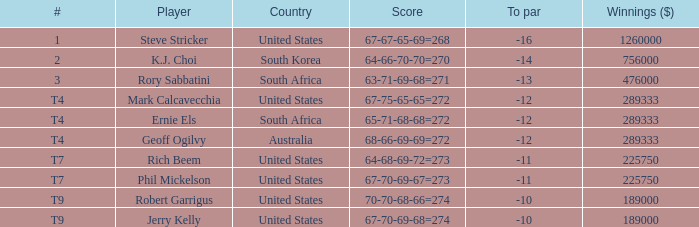Name the number of points for south korea 1.0. 